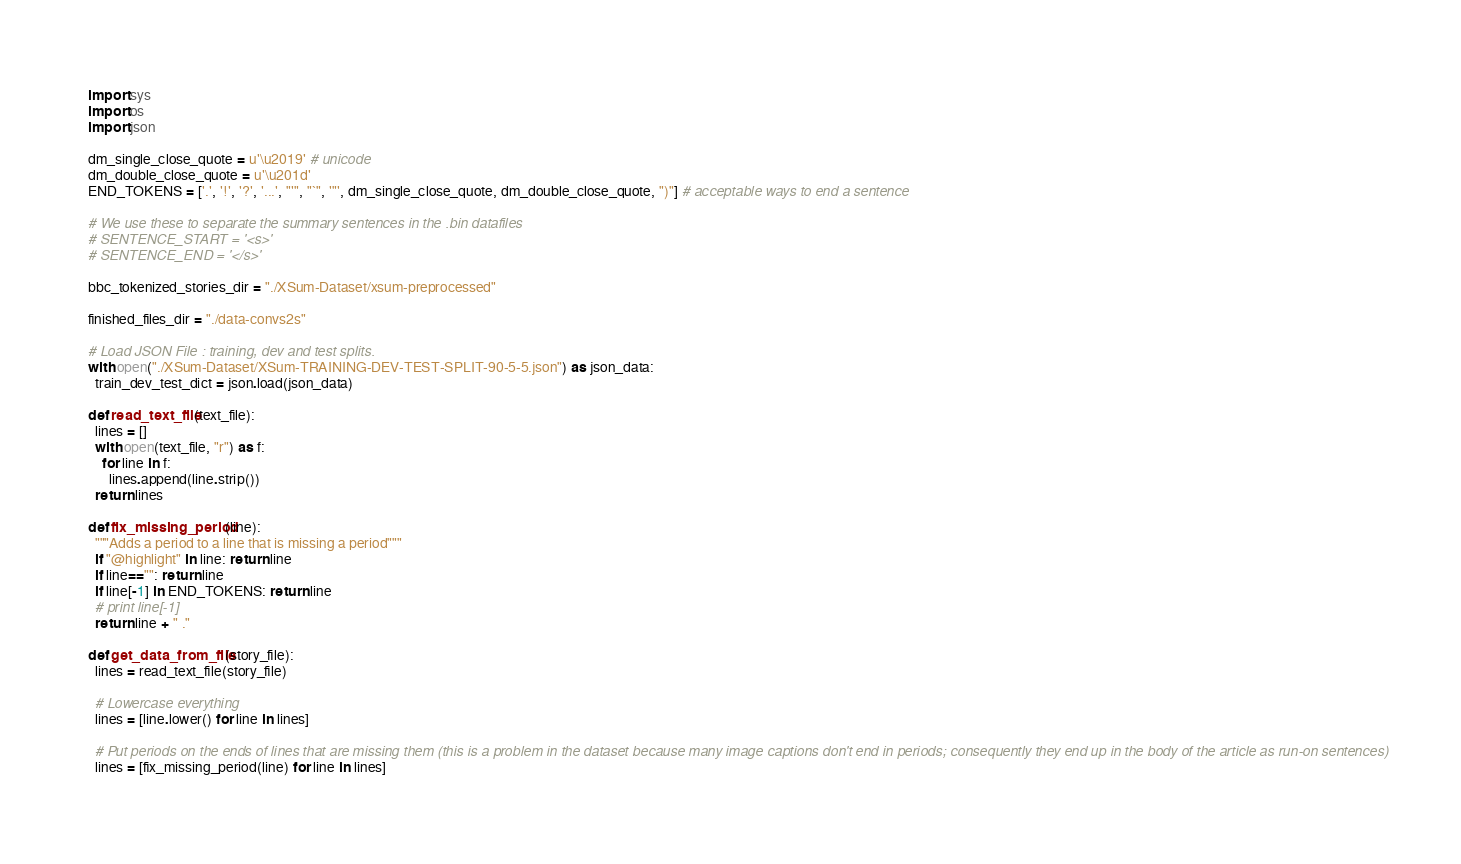<code> <loc_0><loc_0><loc_500><loc_500><_Python_>import sys
import os
import json

dm_single_close_quote = u'\u2019' # unicode
dm_double_close_quote = u'\u201d'
END_TOKENS = ['.', '!', '?', '...', "'", "`", '"', dm_single_close_quote, dm_double_close_quote, ")"] # acceptable ways to end a sentence

# We use these to separate the summary sentences in the .bin datafiles
# SENTENCE_START = '<s>'
# SENTENCE_END = '</s>'

bbc_tokenized_stories_dir = "./XSum-Dataset/xsum-preprocessed"

finished_files_dir = "./data-convs2s"

# Load JSON File : training, dev and test splits.
with open("./XSum-Dataset/XSum-TRAINING-DEV-TEST-SPLIT-90-5-5.json") as json_data:
  train_dev_test_dict = json.load(json_data)

def read_text_file(text_file):
  lines = []
  with open(text_file, "r") as f:
    for line in f:
      lines.append(line.strip())
  return lines

def fix_missing_period(line):
  """Adds a period to a line that is missing a period"""
  if "@highlight" in line: return line
  if line=="": return line
  if line[-1] in END_TOKENS: return line
  # print line[-1]
  return line + " ."

def get_data_from_file(story_file):
  lines = read_text_file(story_file)

  # Lowercase everything
  lines = [line.lower() for line in lines]

  # Put periods on the ends of lines that are missing them (this is a problem in the dataset because many image captions don't end in periods; consequently they end up in the body of the article as run-on sentences)
  lines = [fix_missing_period(line) for line in lines]
</code> 